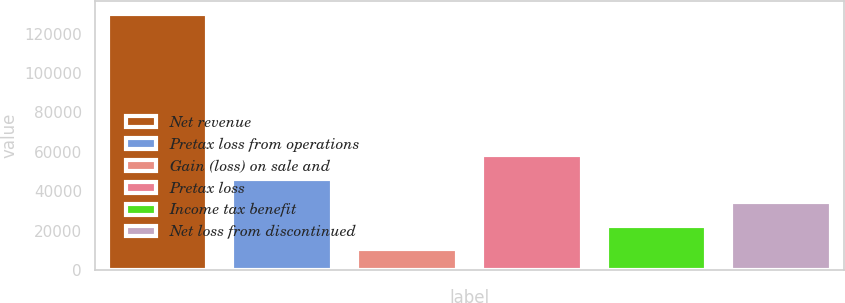Convert chart to OTSL. <chart><loc_0><loc_0><loc_500><loc_500><bar_chart><fcel>Net revenue<fcel>Pretax loss from operations<fcel>Gain (loss) on sale and<fcel>Pretax loss<fcel>Income tax benefit<fcel>Net loss from discontinued<nl><fcel>129863<fcel>46397.1<fcel>10626<fcel>58320.8<fcel>22549.7<fcel>34473.4<nl></chart> 